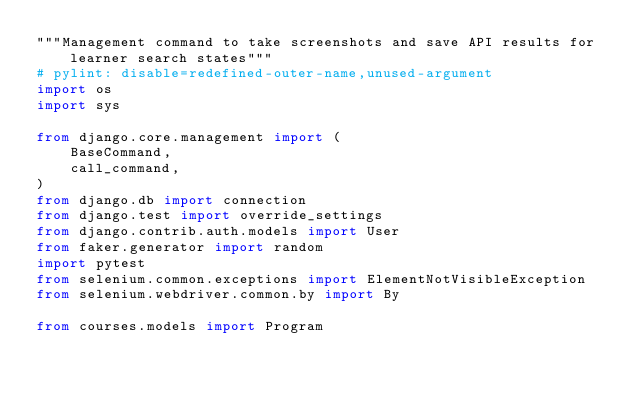Convert code to text. <code><loc_0><loc_0><loc_500><loc_500><_Python_>"""Management command to take screenshots and save API results for learner search states"""
# pylint: disable=redefined-outer-name,unused-argument
import os
import sys

from django.core.management import (
    BaseCommand,
    call_command,
)
from django.db import connection
from django.test import override_settings
from django.contrib.auth.models import User
from faker.generator import random
import pytest
from selenium.common.exceptions import ElementNotVisibleException
from selenium.webdriver.common.by import By

from courses.models import Program</code> 